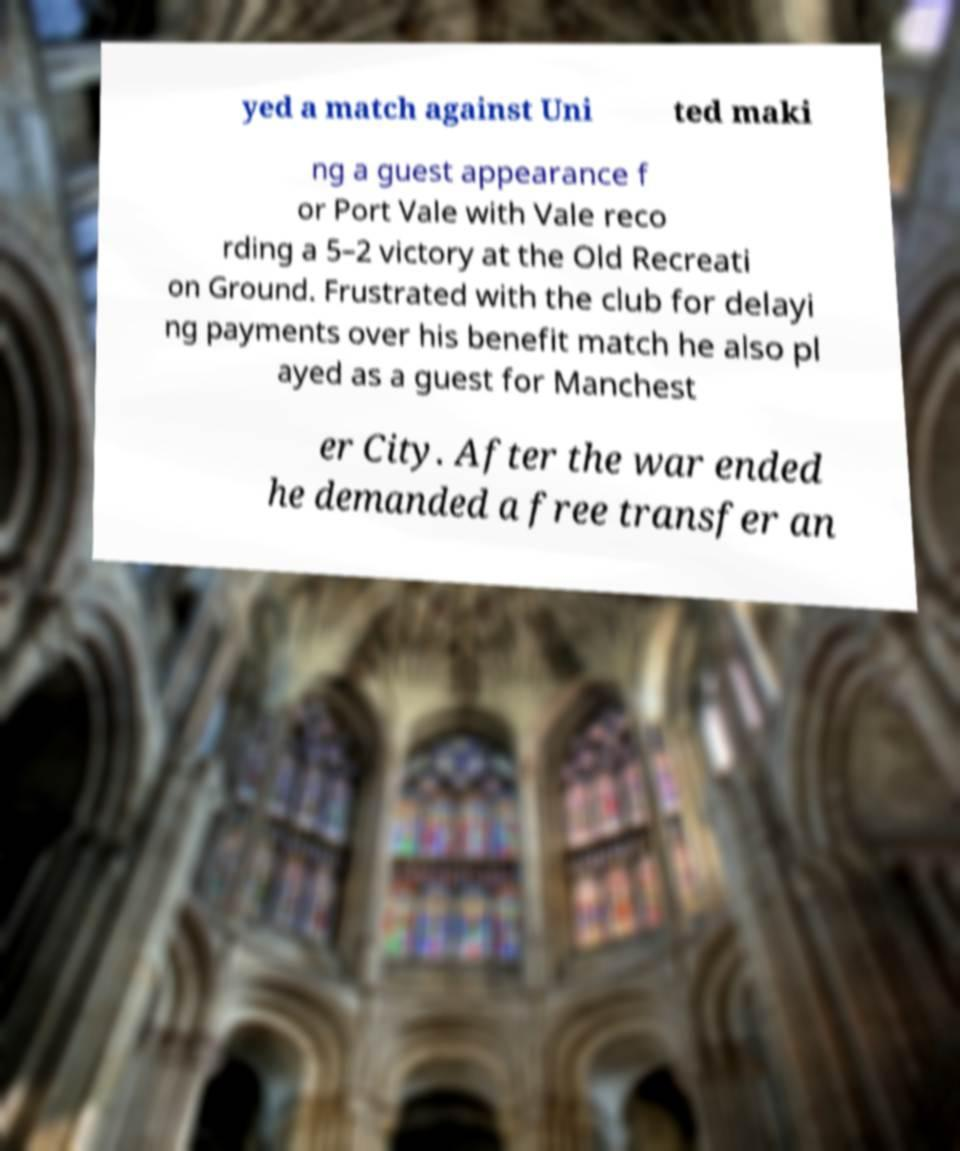Can you accurately transcribe the text from the provided image for me? yed a match against Uni ted maki ng a guest appearance f or Port Vale with Vale reco rding a 5–2 victory at the Old Recreati on Ground. Frustrated with the club for delayi ng payments over his benefit match he also pl ayed as a guest for Manchest er City. After the war ended he demanded a free transfer an 